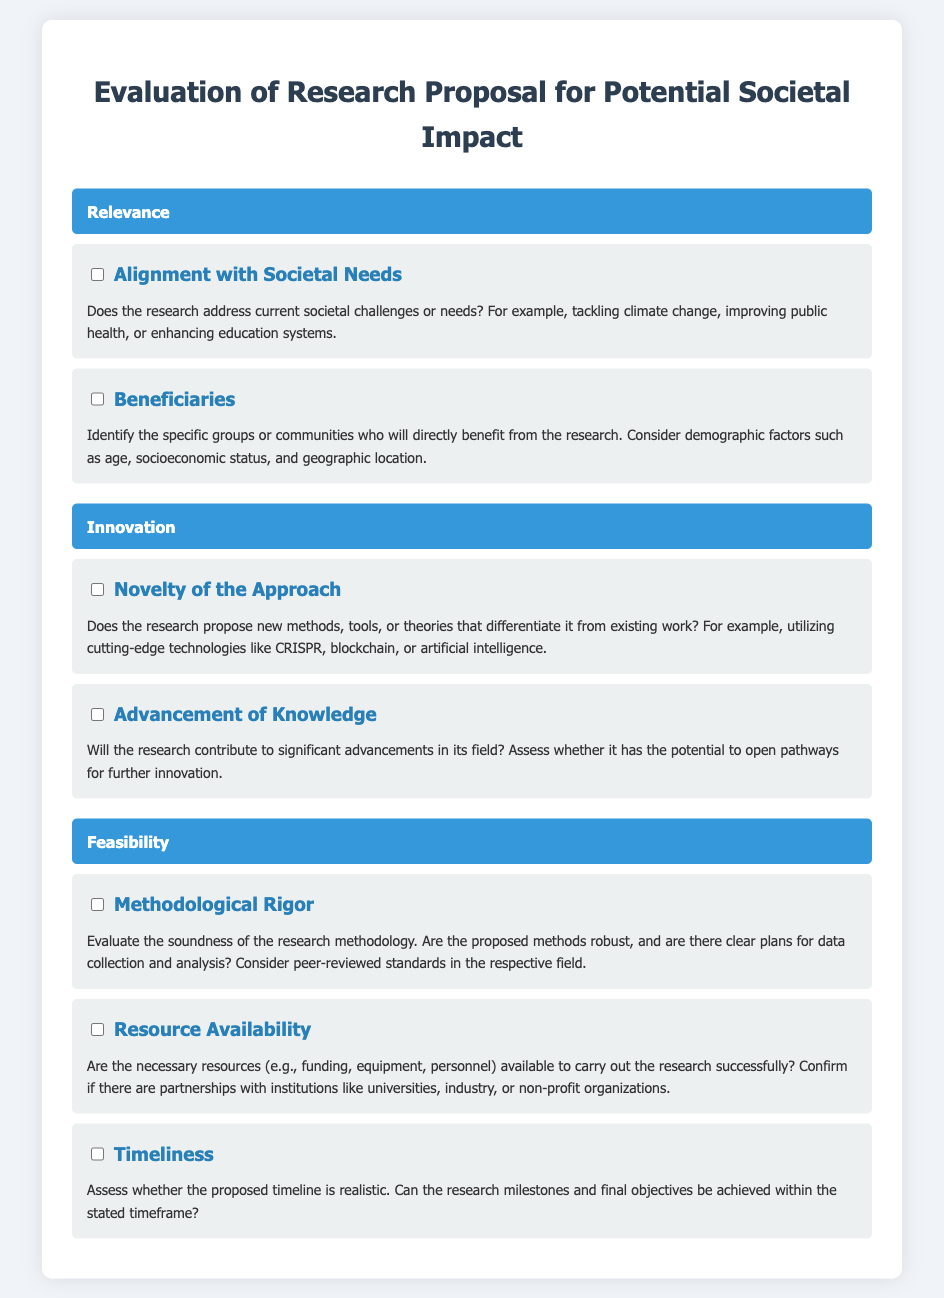What is the title of the checklist? The title of the checklist is stated at the top of the document and describes its purpose, which is to evaluate research proposals.
Answer: Evaluation of Research Proposal for Potential Societal Impact What are the main categories of evaluation in the checklist? The main categories are introduced in separate sections, each focusing on a different aspect of research evaluation.
Answer: Relevance, Innovation, Feasibility What specific groups are to be identified in the relevance section? This detail is mentioned in the 'Beneficiaries' item, specifying the focus on certain demographics.
Answer: Specific groups or communities What aspect does the 'Timeliness' item assess? The 'Timeliness' item evaluates the realism of the proposed timeline in achieving research milestones.
Answer: Realistic timeline Which innovative technologies are referenced in the checklist? The checklist provides examples of technologies that might characterize innovative research approaches.
Answer: CRISPR, blockchain, artificial intelligence What is meant by 'Methodological Rigor'? The checklist item indicates an evaluation of the soundness and robustness of the research methodology.
Answer: Soundness of research methodology What is needed for 'Resource Availability'? This item emphasizes the necessity of sufficient resources for successful research implementation, including funding and partnerships.
Answer: Necessary resources How many items are listed under the 'Innovation' category? The document clearly outlines the number of items included in the Innovation section of the checklist.
Answer: Two items What will the research contribute to, according to the Innovation section? This detail indicates the goal of contributing advancements in the specific field of study.
Answer: Significant advancements 